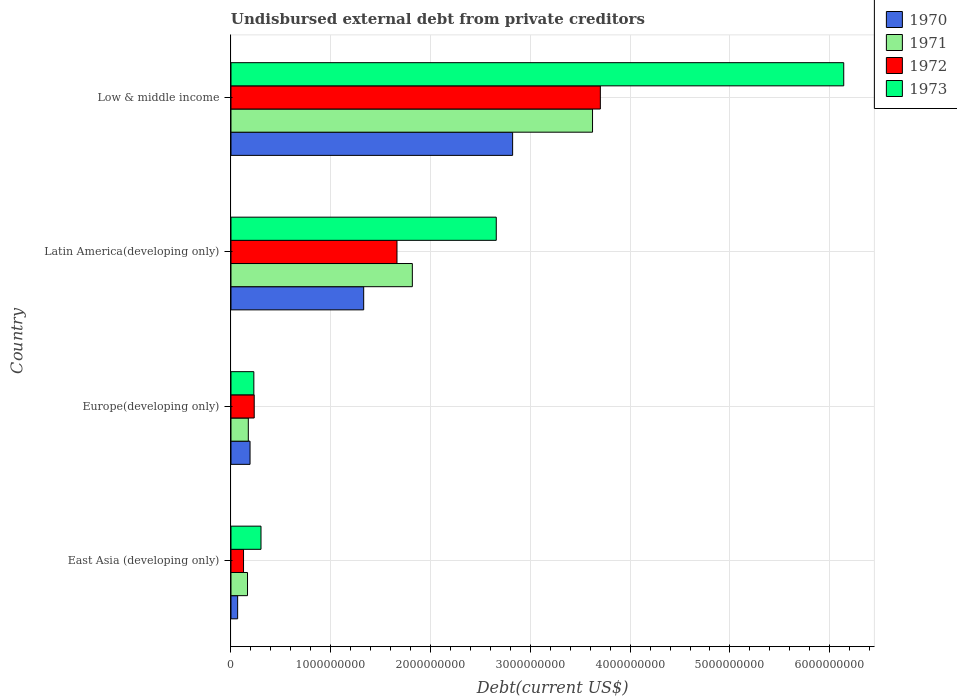Are the number of bars per tick equal to the number of legend labels?
Give a very brief answer. Yes. Are the number of bars on each tick of the Y-axis equal?
Your answer should be compact. Yes. How many bars are there on the 2nd tick from the top?
Ensure brevity in your answer.  4. How many bars are there on the 2nd tick from the bottom?
Ensure brevity in your answer.  4. What is the label of the 4th group of bars from the top?
Your response must be concise. East Asia (developing only). In how many cases, is the number of bars for a given country not equal to the number of legend labels?
Make the answer very short. 0. What is the total debt in 1971 in East Asia (developing only)?
Offer a terse response. 1.66e+08. Across all countries, what is the maximum total debt in 1971?
Your answer should be very brief. 3.62e+09. Across all countries, what is the minimum total debt in 1970?
Your response must be concise. 6.68e+07. In which country was the total debt in 1970 minimum?
Offer a terse response. East Asia (developing only). What is the total total debt in 1971 in the graph?
Provide a succinct answer. 5.78e+09. What is the difference between the total debt in 1970 in Europe(developing only) and that in Latin America(developing only)?
Keep it short and to the point. -1.14e+09. What is the difference between the total debt in 1971 in Europe(developing only) and the total debt in 1970 in Low & middle income?
Provide a succinct answer. -2.65e+09. What is the average total debt in 1972 per country?
Give a very brief answer. 1.43e+09. What is the difference between the total debt in 1973 and total debt in 1970 in East Asia (developing only)?
Offer a very short reply. 2.34e+08. In how many countries, is the total debt in 1971 greater than 4800000000 US$?
Provide a short and direct response. 0. What is the ratio of the total debt in 1972 in East Asia (developing only) to that in Europe(developing only)?
Your response must be concise. 0.54. What is the difference between the highest and the second highest total debt in 1973?
Your answer should be very brief. 3.48e+09. What is the difference between the highest and the lowest total debt in 1970?
Your answer should be very brief. 2.76e+09. In how many countries, is the total debt in 1973 greater than the average total debt in 1973 taken over all countries?
Your answer should be compact. 2. Is it the case that in every country, the sum of the total debt in 1971 and total debt in 1972 is greater than the sum of total debt in 1973 and total debt in 1970?
Make the answer very short. Yes. Is it the case that in every country, the sum of the total debt in 1971 and total debt in 1973 is greater than the total debt in 1972?
Provide a succinct answer. Yes. How many bars are there?
Offer a very short reply. 16. Are all the bars in the graph horizontal?
Keep it short and to the point. Yes. How many countries are there in the graph?
Provide a short and direct response. 4. What is the difference between two consecutive major ticks on the X-axis?
Your answer should be compact. 1.00e+09. Are the values on the major ticks of X-axis written in scientific E-notation?
Your answer should be compact. No. Does the graph contain grids?
Keep it short and to the point. Yes. How many legend labels are there?
Offer a terse response. 4. How are the legend labels stacked?
Offer a terse response. Vertical. What is the title of the graph?
Ensure brevity in your answer.  Undisbursed external debt from private creditors. What is the label or title of the X-axis?
Give a very brief answer. Debt(current US$). What is the label or title of the Y-axis?
Keep it short and to the point. Country. What is the Debt(current US$) in 1970 in East Asia (developing only)?
Your answer should be very brief. 6.68e+07. What is the Debt(current US$) in 1971 in East Asia (developing only)?
Your response must be concise. 1.66e+08. What is the Debt(current US$) of 1972 in East Asia (developing only)?
Your answer should be compact. 1.26e+08. What is the Debt(current US$) in 1973 in East Asia (developing only)?
Offer a terse response. 3.01e+08. What is the Debt(current US$) of 1970 in Europe(developing only)?
Give a very brief answer. 1.91e+08. What is the Debt(current US$) in 1971 in Europe(developing only)?
Provide a succinct answer. 1.74e+08. What is the Debt(current US$) in 1972 in Europe(developing only)?
Make the answer very short. 2.33e+08. What is the Debt(current US$) in 1973 in Europe(developing only)?
Give a very brief answer. 2.29e+08. What is the Debt(current US$) in 1970 in Latin America(developing only)?
Provide a short and direct response. 1.33e+09. What is the Debt(current US$) in 1971 in Latin America(developing only)?
Provide a short and direct response. 1.82e+09. What is the Debt(current US$) of 1972 in Latin America(developing only)?
Ensure brevity in your answer.  1.66e+09. What is the Debt(current US$) in 1973 in Latin America(developing only)?
Your response must be concise. 2.66e+09. What is the Debt(current US$) of 1970 in Low & middle income?
Provide a short and direct response. 2.82e+09. What is the Debt(current US$) in 1971 in Low & middle income?
Provide a short and direct response. 3.62e+09. What is the Debt(current US$) of 1972 in Low & middle income?
Provide a succinct answer. 3.70e+09. What is the Debt(current US$) of 1973 in Low & middle income?
Your answer should be very brief. 6.14e+09. Across all countries, what is the maximum Debt(current US$) of 1970?
Give a very brief answer. 2.82e+09. Across all countries, what is the maximum Debt(current US$) in 1971?
Your answer should be compact. 3.62e+09. Across all countries, what is the maximum Debt(current US$) of 1972?
Your answer should be very brief. 3.70e+09. Across all countries, what is the maximum Debt(current US$) in 1973?
Your answer should be compact. 6.14e+09. Across all countries, what is the minimum Debt(current US$) of 1970?
Provide a succinct answer. 6.68e+07. Across all countries, what is the minimum Debt(current US$) in 1971?
Give a very brief answer. 1.66e+08. Across all countries, what is the minimum Debt(current US$) in 1972?
Give a very brief answer. 1.26e+08. Across all countries, what is the minimum Debt(current US$) of 1973?
Provide a short and direct response. 2.29e+08. What is the total Debt(current US$) of 1970 in the graph?
Ensure brevity in your answer.  4.41e+09. What is the total Debt(current US$) of 1971 in the graph?
Provide a succinct answer. 5.78e+09. What is the total Debt(current US$) in 1972 in the graph?
Keep it short and to the point. 5.72e+09. What is the total Debt(current US$) in 1973 in the graph?
Offer a terse response. 9.33e+09. What is the difference between the Debt(current US$) in 1970 in East Asia (developing only) and that in Europe(developing only)?
Ensure brevity in your answer.  -1.24e+08. What is the difference between the Debt(current US$) in 1971 in East Asia (developing only) and that in Europe(developing only)?
Provide a succinct answer. -7.94e+06. What is the difference between the Debt(current US$) of 1972 in East Asia (developing only) and that in Europe(developing only)?
Make the answer very short. -1.07e+08. What is the difference between the Debt(current US$) in 1973 in East Asia (developing only) and that in Europe(developing only)?
Your response must be concise. 7.16e+07. What is the difference between the Debt(current US$) of 1970 in East Asia (developing only) and that in Latin America(developing only)?
Provide a succinct answer. -1.26e+09. What is the difference between the Debt(current US$) of 1971 in East Asia (developing only) and that in Latin America(developing only)?
Offer a very short reply. -1.65e+09. What is the difference between the Debt(current US$) in 1972 in East Asia (developing only) and that in Latin America(developing only)?
Make the answer very short. -1.54e+09. What is the difference between the Debt(current US$) in 1973 in East Asia (developing only) and that in Latin America(developing only)?
Offer a terse response. -2.36e+09. What is the difference between the Debt(current US$) of 1970 in East Asia (developing only) and that in Low & middle income?
Ensure brevity in your answer.  -2.76e+09. What is the difference between the Debt(current US$) in 1971 in East Asia (developing only) and that in Low & middle income?
Ensure brevity in your answer.  -3.46e+09. What is the difference between the Debt(current US$) of 1972 in East Asia (developing only) and that in Low & middle income?
Make the answer very short. -3.58e+09. What is the difference between the Debt(current US$) of 1973 in East Asia (developing only) and that in Low & middle income?
Your answer should be very brief. -5.84e+09. What is the difference between the Debt(current US$) of 1970 in Europe(developing only) and that in Latin America(developing only)?
Offer a very short reply. -1.14e+09. What is the difference between the Debt(current US$) in 1971 in Europe(developing only) and that in Latin America(developing only)?
Give a very brief answer. -1.64e+09. What is the difference between the Debt(current US$) of 1972 in Europe(developing only) and that in Latin America(developing only)?
Your answer should be very brief. -1.43e+09. What is the difference between the Debt(current US$) of 1973 in Europe(developing only) and that in Latin America(developing only)?
Provide a succinct answer. -2.43e+09. What is the difference between the Debt(current US$) in 1970 in Europe(developing only) and that in Low & middle income?
Provide a succinct answer. -2.63e+09. What is the difference between the Debt(current US$) of 1971 in Europe(developing only) and that in Low & middle income?
Provide a short and direct response. -3.45e+09. What is the difference between the Debt(current US$) in 1972 in Europe(developing only) and that in Low & middle income?
Offer a very short reply. -3.47e+09. What is the difference between the Debt(current US$) in 1973 in Europe(developing only) and that in Low & middle income?
Provide a succinct answer. -5.91e+09. What is the difference between the Debt(current US$) in 1970 in Latin America(developing only) and that in Low & middle income?
Offer a terse response. -1.49e+09. What is the difference between the Debt(current US$) of 1971 in Latin America(developing only) and that in Low & middle income?
Ensure brevity in your answer.  -1.81e+09. What is the difference between the Debt(current US$) in 1972 in Latin America(developing only) and that in Low & middle income?
Provide a succinct answer. -2.04e+09. What is the difference between the Debt(current US$) of 1973 in Latin America(developing only) and that in Low & middle income?
Provide a short and direct response. -3.48e+09. What is the difference between the Debt(current US$) in 1970 in East Asia (developing only) and the Debt(current US$) in 1971 in Europe(developing only)?
Your answer should be compact. -1.07e+08. What is the difference between the Debt(current US$) in 1970 in East Asia (developing only) and the Debt(current US$) in 1972 in Europe(developing only)?
Your answer should be compact. -1.66e+08. What is the difference between the Debt(current US$) in 1970 in East Asia (developing only) and the Debt(current US$) in 1973 in Europe(developing only)?
Provide a succinct answer. -1.62e+08. What is the difference between the Debt(current US$) of 1971 in East Asia (developing only) and the Debt(current US$) of 1972 in Europe(developing only)?
Your answer should be compact. -6.72e+07. What is the difference between the Debt(current US$) in 1971 in East Asia (developing only) and the Debt(current US$) in 1973 in Europe(developing only)?
Your answer should be compact. -6.35e+07. What is the difference between the Debt(current US$) in 1972 in East Asia (developing only) and the Debt(current US$) in 1973 in Europe(developing only)?
Ensure brevity in your answer.  -1.03e+08. What is the difference between the Debt(current US$) of 1970 in East Asia (developing only) and the Debt(current US$) of 1971 in Latin America(developing only)?
Your response must be concise. -1.75e+09. What is the difference between the Debt(current US$) in 1970 in East Asia (developing only) and the Debt(current US$) in 1972 in Latin America(developing only)?
Make the answer very short. -1.60e+09. What is the difference between the Debt(current US$) in 1970 in East Asia (developing only) and the Debt(current US$) in 1973 in Latin America(developing only)?
Give a very brief answer. -2.59e+09. What is the difference between the Debt(current US$) of 1971 in East Asia (developing only) and the Debt(current US$) of 1972 in Latin America(developing only)?
Offer a terse response. -1.50e+09. What is the difference between the Debt(current US$) of 1971 in East Asia (developing only) and the Debt(current US$) of 1973 in Latin America(developing only)?
Provide a short and direct response. -2.49e+09. What is the difference between the Debt(current US$) in 1972 in East Asia (developing only) and the Debt(current US$) in 1973 in Latin America(developing only)?
Provide a succinct answer. -2.53e+09. What is the difference between the Debt(current US$) of 1970 in East Asia (developing only) and the Debt(current US$) of 1971 in Low & middle income?
Your answer should be very brief. -3.56e+09. What is the difference between the Debt(current US$) of 1970 in East Asia (developing only) and the Debt(current US$) of 1972 in Low & middle income?
Offer a very short reply. -3.63e+09. What is the difference between the Debt(current US$) in 1970 in East Asia (developing only) and the Debt(current US$) in 1973 in Low & middle income?
Ensure brevity in your answer.  -6.07e+09. What is the difference between the Debt(current US$) in 1971 in East Asia (developing only) and the Debt(current US$) in 1972 in Low & middle income?
Offer a terse response. -3.54e+09. What is the difference between the Debt(current US$) of 1971 in East Asia (developing only) and the Debt(current US$) of 1973 in Low & middle income?
Provide a succinct answer. -5.97e+09. What is the difference between the Debt(current US$) of 1972 in East Asia (developing only) and the Debt(current US$) of 1973 in Low & middle income?
Your answer should be compact. -6.01e+09. What is the difference between the Debt(current US$) in 1970 in Europe(developing only) and the Debt(current US$) in 1971 in Latin America(developing only)?
Your response must be concise. -1.63e+09. What is the difference between the Debt(current US$) of 1970 in Europe(developing only) and the Debt(current US$) of 1972 in Latin America(developing only)?
Provide a succinct answer. -1.47e+09. What is the difference between the Debt(current US$) of 1970 in Europe(developing only) and the Debt(current US$) of 1973 in Latin America(developing only)?
Make the answer very short. -2.47e+09. What is the difference between the Debt(current US$) of 1971 in Europe(developing only) and the Debt(current US$) of 1972 in Latin America(developing only)?
Your answer should be compact. -1.49e+09. What is the difference between the Debt(current US$) of 1971 in Europe(developing only) and the Debt(current US$) of 1973 in Latin America(developing only)?
Make the answer very short. -2.48e+09. What is the difference between the Debt(current US$) of 1972 in Europe(developing only) and the Debt(current US$) of 1973 in Latin America(developing only)?
Provide a short and direct response. -2.43e+09. What is the difference between the Debt(current US$) of 1970 in Europe(developing only) and the Debt(current US$) of 1971 in Low & middle income?
Your response must be concise. -3.43e+09. What is the difference between the Debt(current US$) in 1970 in Europe(developing only) and the Debt(current US$) in 1972 in Low & middle income?
Ensure brevity in your answer.  -3.51e+09. What is the difference between the Debt(current US$) of 1970 in Europe(developing only) and the Debt(current US$) of 1973 in Low & middle income?
Your answer should be compact. -5.95e+09. What is the difference between the Debt(current US$) in 1971 in Europe(developing only) and the Debt(current US$) in 1972 in Low & middle income?
Provide a succinct answer. -3.53e+09. What is the difference between the Debt(current US$) of 1971 in Europe(developing only) and the Debt(current US$) of 1973 in Low & middle income?
Your response must be concise. -5.97e+09. What is the difference between the Debt(current US$) of 1972 in Europe(developing only) and the Debt(current US$) of 1973 in Low & middle income?
Provide a short and direct response. -5.91e+09. What is the difference between the Debt(current US$) of 1970 in Latin America(developing only) and the Debt(current US$) of 1971 in Low & middle income?
Offer a terse response. -2.29e+09. What is the difference between the Debt(current US$) of 1970 in Latin America(developing only) and the Debt(current US$) of 1972 in Low & middle income?
Offer a very short reply. -2.37e+09. What is the difference between the Debt(current US$) in 1970 in Latin America(developing only) and the Debt(current US$) in 1973 in Low & middle income?
Provide a succinct answer. -4.81e+09. What is the difference between the Debt(current US$) in 1971 in Latin America(developing only) and the Debt(current US$) in 1972 in Low & middle income?
Your answer should be compact. -1.88e+09. What is the difference between the Debt(current US$) in 1971 in Latin America(developing only) and the Debt(current US$) in 1973 in Low & middle income?
Ensure brevity in your answer.  -4.32e+09. What is the difference between the Debt(current US$) in 1972 in Latin America(developing only) and the Debt(current US$) in 1973 in Low & middle income?
Keep it short and to the point. -4.48e+09. What is the average Debt(current US$) of 1970 per country?
Make the answer very short. 1.10e+09. What is the average Debt(current US$) in 1971 per country?
Ensure brevity in your answer.  1.45e+09. What is the average Debt(current US$) of 1972 per country?
Keep it short and to the point. 1.43e+09. What is the average Debt(current US$) in 1973 per country?
Provide a short and direct response. 2.33e+09. What is the difference between the Debt(current US$) in 1970 and Debt(current US$) in 1971 in East Asia (developing only)?
Keep it short and to the point. -9.89e+07. What is the difference between the Debt(current US$) of 1970 and Debt(current US$) of 1972 in East Asia (developing only)?
Give a very brief answer. -5.90e+07. What is the difference between the Debt(current US$) of 1970 and Debt(current US$) of 1973 in East Asia (developing only)?
Your answer should be compact. -2.34e+08. What is the difference between the Debt(current US$) in 1971 and Debt(current US$) in 1972 in East Asia (developing only)?
Make the answer very short. 3.99e+07. What is the difference between the Debt(current US$) of 1971 and Debt(current US$) of 1973 in East Asia (developing only)?
Provide a succinct answer. -1.35e+08. What is the difference between the Debt(current US$) of 1972 and Debt(current US$) of 1973 in East Asia (developing only)?
Your answer should be compact. -1.75e+08. What is the difference between the Debt(current US$) in 1970 and Debt(current US$) in 1971 in Europe(developing only)?
Keep it short and to the point. 1.74e+07. What is the difference between the Debt(current US$) in 1970 and Debt(current US$) in 1972 in Europe(developing only)?
Provide a short and direct response. -4.19e+07. What is the difference between the Debt(current US$) of 1970 and Debt(current US$) of 1973 in Europe(developing only)?
Offer a very short reply. -3.81e+07. What is the difference between the Debt(current US$) in 1971 and Debt(current US$) in 1972 in Europe(developing only)?
Ensure brevity in your answer.  -5.92e+07. What is the difference between the Debt(current US$) in 1971 and Debt(current US$) in 1973 in Europe(developing only)?
Ensure brevity in your answer.  -5.55e+07. What is the difference between the Debt(current US$) in 1972 and Debt(current US$) in 1973 in Europe(developing only)?
Provide a succinct answer. 3.73e+06. What is the difference between the Debt(current US$) of 1970 and Debt(current US$) of 1971 in Latin America(developing only)?
Keep it short and to the point. -4.88e+08. What is the difference between the Debt(current US$) of 1970 and Debt(current US$) of 1972 in Latin America(developing only)?
Keep it short and to the point. -3.34e+08. What is the difference between the Debt(current US$) of 1970 and Debt(current US$) of 1973 in Latin America(developing only)?
Offer a terse response. -1.33e+09. What is the difference between the Debt(current US$) in 1971 and Debt(current US$) in 1972 in Latin America(developing only)?
Keep it short and to the point. 1.54e+08. What is the difference between the Debt(current US$) in 1971 and Debt(current US$) in 1973 in Latin America(developing only)?
Offer a terse response. -8.41e+08. What is the difference between the Debt(current US$) of 1972 and Debt(current US$) of 1973 in Latin America(developing only)?
Your response must be concise. -9.95e+08. What is the difference between the Debt(current US$) of 1970 and Debt(current US$) of 1971 in Low & middle income?
Your answer should be very brief. -8.01e+08. What is the difference between the Debt(current US$) in 1970 and Debt(current US$) in 1972 in Low & middle income?
Provide a short and direct response. -8.79e+08. What is the difference between the Debt(current US$) of 1970 and Debt(current US$) of 1973 in Low & middle income?
Provide a succinct answer. -3.32e+09. What is the difference between the Debt(current US$) of 1971 and Debt(current US$) of 1972 in Low & middle income?
Your answer should be compact. -7.84e+07. What is the difference between the Debt(current US$) in 1971 and Debt(current US$) in 1973 in Low & middle income?
Make the answer very short. -2.52e+09. What is the difference between the Debt(current US$) in 1972 and Debt(current US$) in 1973 in Low & middle income?
Ensure brevity in your answer.  -2.44e+09. What is the ratio of the Debt(current US$) in 1970 in East Asia (developing only) to that in Europe(developing only)?
Keep it short and to the point. 0.35. What is the ratio of the Debt(current US$) of 1971 in East Asia (developing only) to that in Europe(developing only)?
Give a very brief answer. 0.95. What is the ratio of the Debt(current US$) in 1972 in East Asia (developing only) to that in Europe(developing only)?
Make the answer very short. 0.54. What is the ratio of the Debt(current US$) in 1973 in East Asia (developing only) to that in Europe(developing only)?
Offer a terse response. 1.31. What is the ratio of the Debt(current US$) of 1970 in East Asia (developing only) to that in Latin America(developing only)?
Provide a short and direct response. 0.05. What is the ratio of the Debt(current US$) of 1971 in East Asia (developing only) to that in Latin America(developing only)?
Offer a very short reply. 0.09. What is the ratio of the Debt(current US$) of 1972 in East Asia (developing only) to that in Latin America(developing only)?
Provide a short and direct response. 0.08. What is the ratio of the Debt(current US$) of 1973 in East Asia (developing only) to that in Latin America(developing only)?
Your answer should be very brief. 0.11. What is the ratio of the Debt(current US$) of 1970 in East Asia (developing only) to that in Low & middle income?
Your answer should be very brief. 0.02. What is the ratio of the Debt(current US$) of 1971 in East Asia (developing only) to that in Low & middle income?
Your answer should be very brief. 0.05. What is the ratio of the Debt(current US$) of 1972 in East Asia (developing only) to that in Low & middle income?
Provide a succinct answer. 0.03. What is the ratio of the Debt(current US$) of 1973 in East Asia (developing only) to that in Low & middle income?
Give a very brief answer. 0.05. What is the ratio of the Debt(current US$) of 1970 in Europe(developing only) to that in Latin America(developing only)?
Keep it short and to the point. 0.14. What is the ratio of the Debt(current US$) of 1971 in Europe(developing only) to that in Latin America(developing only)?
Provide a short and direct response. 0.1. What is the ratio of the Debt(current US$) in 1972 in Europe(developing only) to that in Latin America(developing only)?
Your answer should be very brief. 0.14. What is the ratio of the Debt(current US$) in 1973 in Europe(developing only) to that in Latin America(developing only)?
Offer a very short reply. 0.09. What is the ratio of the Debt(current US$) of 1970 in Europe(developing only) to that in Low & middle income?
Keep it short and to the point. 0.07. What is the ratio of the Debt(current US$) of 1971 in Europe(developing only) to that in Low & middle income?
Offer a terse response. 0.05. What is the ratio of the Debt(current US$) in 1972 in Europe(developing only) to that in Low & middle income?
Provide a short and direct response. 0.06. What is the ratio of the Debt(current US$) of 1973 in Europe(developing only) to that in Low & middle income?
Your answer should be very brief. 0.04. What is the ratio of the Debt(current US$) in 1970 in Latin America(developing only) to that in Low & middle income?
Your response must be concise. 0.47. What is the ratio of the Debt(current US$) of 1971 in Latin America(developing only) to that in Low & middle income?
Make the answer very short. 0.5. What is the ratio of the Debt(current US$) of 1972 in Latin America(developing only) to that in Low & middle income?
Give a very brief answer. 0.45. What is the ratio of the Debt(current US$) in 1973 in Latin America(developing only) to that in Low & middle income?
Keep it short and to the point. 0.43. What is the difference between the highest and the second highest Debt(current US$) of 1970?
Your answer should be compact. 1.49e+09. What is the difference between the highest and the second highest Debt(current US$) of 1971?
Ensure brevity in your answer.  1.81e+09. What is the difference between the highest and the second highest Debt(current US$) in 1972?
Give a very brief answer. 2.04e+09. What is the difference between the highest and the second highest Debt(current US$) of 1973?
Offer a terse response. 3.48e+09. What is the difference between the highest and the lowest Debt(current US$) of 1970?
Keep it short and to the point. 2.76e+09. What is the difference between the highest and the lowest Debt(current US$) of 1971?
Your response must be concise. 3.46e+09. What is the difference between the highest and the lowest Debt(current US$) of 1972?
Keep it short and to the point. 3.58e+09. What is the difference between the highest and the lowest Debt(current US$) of 1973?
Provide a short and direct response. 5.91e+09. 